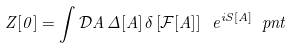Convert formula to latex. <formula><loc_0><loc_0><loc_500><loc_500>Z [ 0 ] = \int \mathcal { D } A \, \Delta [ A ] \, \delta \left [ \mathcal { F } [ A ] \right ] \ e ^ { i S [ A ] } \ p n t</formula> 